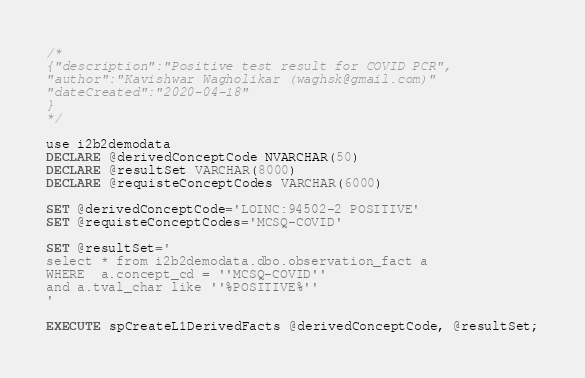Convert code to text. <code><loc_0><loc_0><loc_500><loc_500><_SQL_>
/*
{"description":"Positive test result for COVID PCR",
"author":"Kavishwar Wagholikar (waghsk@gmail.com)"
"dateCreated":"2020-04-18"
}
*/

use i2b2demodata
DECLARE @derivedConceptCode NVARCHAR(50)
DECLARE @resultSet VARCHAR(8000)
DECLARE @requisteConceptCodes VARCHAR(6000)

SET @derivedConceptCode='LOINC:94502-2 POSITIVE'
SET @requisteConceptCodes='MCSQ-COVID'

SET @resultSet='
select * from i2b2demodata.dbo.observation_fact a
WHERE  a.concept_cd = ''MCSQ-COVID''
and a.tval_char like ''%POSITIVE%''
'

EXECUTE spCreateL1DerivedFacts @derivedConceptCode, @resultSet;




</code> 